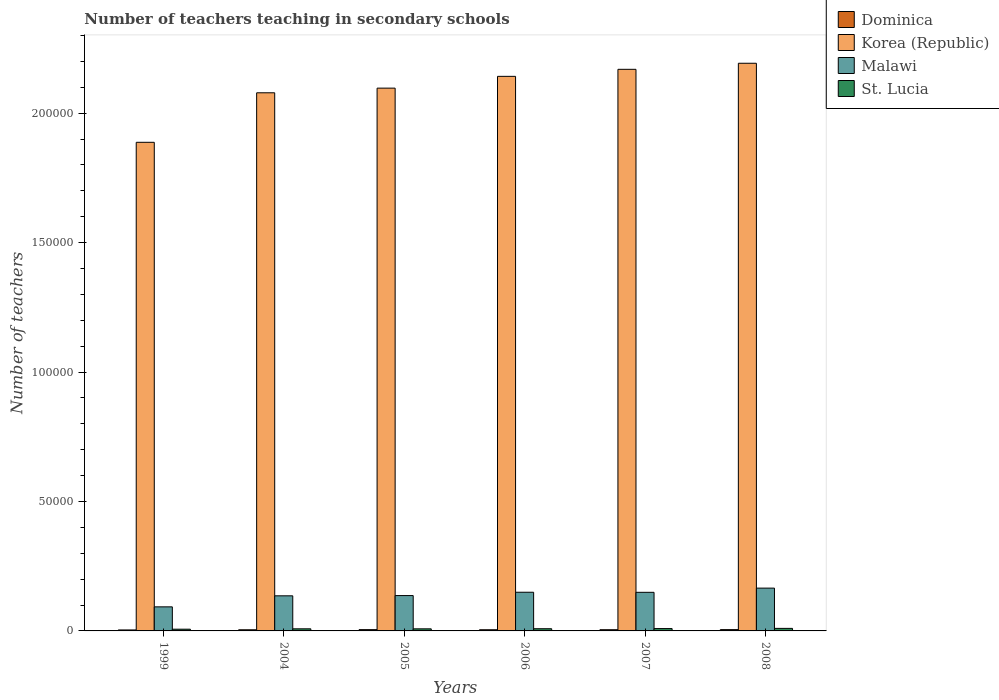How many groups of bars are there?
Provide a succinct answer. 6. Are the number of bars on each tick of the X-axis equal?
Make the answer very short. Yes. What is the label of the 5th group of bars from the left?
Your answer should be compact. 2007. In how many cases, is the number of bars for a given year not equal to the number of legend labels?
Give a very brief answer. 0. What is the number of teachers teaching in secondary schools in Malawi in 2006?
Keep it short and to the point. 1.49e+04. Across all years, what is the maximum number of teachers teaching in secondary schools in Dominica?
Provide a short and direct response. 506. Across all years, what is the minimum number of teachers teaching in secondary schools in Korea (Republic)?
Your answer should be very brief. 1.89e+05. What is the total number of teachers teaching in secondary schools in St. Lucia in the graph?
Your response must be concise. 5017. What is the difference between the number of teachers teaching in secondary schools in Malawi in 1999 and that in 2005?
Your response must be concise. -4358. What is the difference between the number of teachers teaching in secondary schools in Malawi in 2008 and the number of teachers teaching in secondary schools in Korea (Republic) in 2004?
Provide a short and direct response. -1.91e+05. What is the average number of teachers teaching in secondary schools in St. Lucia per year?
Your answer should be very brief. 836.17. In the year 1999, what is the difference between the number of teachers teaching in secondary schools in St. Lucia and number of teachers teaching in secondary schools in Dominica?
Make the answer very short. 293. What is the ratio of the number of teachers teaching in secondary schools in Dominica in 2004 to that in 2005?
Ensure brevity in your answer.  0.9. Is the number of teachers teaching in secondary schools in Malawi in 2005 less than that in 2007?
Provide a short and direct response. Yes. What is the difference between the highest and the second highest number of teachers teaching in secondary schools in Malawi?
Keep it short and to the point. 1596. What is the difference between the highest and the lowest number of teachers teaching in secondary schools in Dominica?
Offer a very short reply. 130. In how many years, is the number of teachers teaching in secondary schools in St. Lucia greater than the average number of teachers teaching in secondary schools in St. Lucia taken over all years?
Keep it short and to the point. 3. Is it the case that in every year, the sum of the number of teachers teaching in secondary schools in Dominica and number of teachers teaching in secondary schools in St. Lucia is greater than the sum of number of teachers teaching in secondary schools in Korea (Republic) and number of teachers teaching in secondary schools in Malawi?
Offer a terse response. Yes. What does the 4th bar from the left in 2007 represents?
Provide a short and direct response. St. Lucia. What does the 1st bar from the right in 2007 represents?
Offer a very short reply. St. Lucia. Is it the case that in every year, the sum of the number of teachers teaching in secondary schools in Korea (Republic) and number of teachers teaching in secondary schools in Malawi is greater than the number of teachers teaching in secondary schools in Dominica?
Provide a short and direct response. Yes. Are all the bars in the graph horizontal?
Ensure brevity in your answer.  No. How many years are there in the graph?
Keep it short and to the point. 6. What is the difference between two consecutive major ticks on the Y-axis?
Provide a succinct answer. 5.00e+04. Where does the legend appear in the graph?
Your answer should be compact. Top right. What is the title of the graph?
Offer a terse response. Number of teachers teaching in secondary schools. What is the label or title of the Y-axis?
Offer a very short reply. Number of teachers. What is the Number of teachers of Dominica in 1999?
Give a very brief answer. 376. What is the Number of teachers in Korea (Republic) in 1999?
Your response must be concise. 1.89e+05. What is the Number of teachers in Malawi in 1999?
Your answer should be compact. 9301. What is the Number of teachers in St. Lucia in 1999?
Keep it short and to the point. 669. What is the Number of teachers of Dominica in 2004?
Your response must be concise. 445. What is the Number of teachers in Korea (Republic) in 2004?
Offer a terse response. 2.08e+05. What is the Number of teachers of Malawi in 2004?
Offer a very short reply. 1.36e+04. What is the Number of teachers of St. Lucia in 2004?
Your answer should be compact. 814. What is the Number of teachers in Dominica in 2005?
Provide a short and direct response. 496. What is the Number of teachers of Korea (Republic) in 2005?
Keep it short and to the point. 2.10e+05. What is the Number of teachers in Malawi in 2005?
Ensure brevity in your answer.  1.37e+04. What is the Number of teachers of St. Lucia in 2005?
Make the answer very short. 803. What is the Number of teachers of Dominica in 2006?
Make the answer very short. 455. What is the Number of teachers of Korea (Republic) in 2006?
Keep it short and to the point. 2.14e+05. What is the Number of teachers in Malawi in 2006?
Offer a very short reply. 1.49e+04. What is the Number of teachers in St. Lucia in 2006?
Offer a terse response. 845. What is the Number of teachers of Dominica in 2007?
Offer a terse response. 469. What is the Number of teachers in Korea (Republic) in 2007?
Offer a terse response. 2.17e+05. What is the Number of teachers of Malawi in 2007?
Offer a terse response. 1.49e+04. What is the Number of teachers in St. Lucia in 2007?
Your answer should be compact. 907. What is the Number of teachers of Dominica in 2008?
Your answer should be very brief. 506. What is the Number of teachers in Korea (Republic) in 2008?
Your answer should be compact. 2.19e+05. What is the Number of teachers in Malawi in 2008?
Your answer should be very brief. 1.65e+04. What is the Number of teachers in St. Lucia in 2008?
Offer a very short reply. 979. Across all years, what is the maximum Number of teachers of Dominica?
Your answer should be compact. 506. Across all years, what is the maximum Number of teachers in Korea (Republic)?
Make the answer very short. 2.19e+05. Across all years, what is the maximum Number of teachers in Malawi?
Your response must be concise. 1.65e+04. Across all years, what is the maximum Number of teachers of St. Lucia?
Your answer should be compact. 979. Across all years, what is the minimum Number of teachers of Dominica?
Give a very brief answer. 376. Across all years, what is the minimum Number of teachers in Korea (Republic)?
Your answer should be compact. 1.89e+05. Across all years, what is the minimum Number of teachers in Malawi?
Offer a very short reply. 9301. Across all years, what is the minimum Number of teachers in St. Lucia?
Ensure brevity in your answer.  669. What is the total Number of teachers in Dominica in the graph?
Keep it short and to the point. 2747. What is the total Number of teachers in Korea (Republic) in the graph?
Make the answer very short. 1.26e+06. What is the total Number of teachers in Malawi in the graph?
Offer a very short reply. 8.29e+04. What is the total Number of teachers in St. Lucia in the graph?
Keep it short and to the point. 5017. What is the difference between the Number of teachers in Dominica in 1999 and that in 2004?
Your response must be concise. -69. What is the difference between the Number of teachers of Korea (Republic) in 1999 and that in 2004?
Make the answer very short. -1.91e+04. What is the difference between the Number of teachers of Malawi in 1999 and that in 2004?
Provide a succinct answer. -4256. What is the difference between the Number of teachers in St. Lucia in 1999 and that in 2004?
Your response must be concise. -145. What is the difference between the Number of teachers of Dominica in 1999 and that in 2005?
Your response must be concise. -120. What is the difference between the Number of teachers in Korea (Republic) in 1999 and that in 2005?
Keep it short and to the point. -2.09e+04. What is the difference between the Number of teachers of Malawi in 1999 and that in 2005?
Ensure brevity in your answer.  -4358. What is the difference between the Number of teachers of St. Lucia in 1999 and that in 2005?
Provide a short and direct response. -134. What is the difference between the Number of teachers in Dominica in 1999 and that in 2006?
Your answer should be very brief. -79. What is the difference between the Number of teachers of Korea (Republic) in 1999 and that in 2006?
Offer a very short reply. -2.55e+04. What is the difference between the Number of teachers in Malawi in 1999 and that in 2006?
Give a very brief answer. -5638. What is the difference between the Number of teachers of St. Lucia in 1999 and that in 2006?
Ensure brevity in your answer.  -176. What is the difference between the Number of teachers in Dominica in 1999 and that in 2007?
Make the answer very short. -93. What is the difference between the Number of teachers in Korea (Republic) in 1999 and that in 2007?
Your response must be concise. -2.82e+04. What is the difference between the Number of teachers in Malawi in 1999 and that in 2007?
Ensure brevity in your answer.  -5612. What is the difference between the Number of teachers of St. Lucia in 1999 and that in 2007?
Offer a terse response. -238. What is the difference between the Number of teachers of Dominica in 1999 and that in 2008?
Keep it short and to the point. -130. What is the difference between the Number of teachers of Korea (Republic) in 1999 and that in 2008?
Your answer should be very brief. -3.05e+04. What is the difference between the Number of teachers of Malawi in 1999 and that in 2008?
Ensure brevity in your answer.  -7234. What is the difference between the Number of teachers of St. Lucia in 1999 and that in 2008?
Give a very brief answer. -310. What is the difference between the Number of teachers of Dominica in 2004 and that in 2005?
Ensure brevity in your answer.  -51. What is the difference between the Number of teachers in Korea (Republic) in 2004 and that in 2005?
Provide a short and direct response. -1798. What is the difference between the Number of teachers in Malawi in 2004 and that in 2005?
Offer a terse response. -102. What is the difference between the Number of teachers of Dominica in 2004 and that in 2006?
Your response must be concise. -10. What is the difference between the Number of teachers of Korea (Republic) in 2004 and that in 2006?
Keep it short and to the point. -6350. What is the difference between the Number of teachers in Malawi in 2004 and that in 2006?
Give a very brief answer. -1382. What is the difference between the Number of teachers of St. Lucia in 2004 and that in 2006?
Your answer should be compact. -31. What is the difference between the Number of teachers of Korea (Republic) in 2004 and that in 2007?
Ensure brevity in your answer.  -9069. What is the difference between the Number of teachers of Malawi in 2004 and that in 2007?
Keep it short and to the point. -1356. What is the difference between the Number of teachers in St. Lucia in 2004 and that in 2007?
Ensure brevity in your answer.  -93. What is the difference between the Number of teachers in Dominica in 2004 and that in 2008?
Offer a terse response. -61. What is the difference between the Number of teachers of Korea (Republic) in 2004 and that in 2008?
Keep it short and to the point. -1.14e+04. What is the difference between the Number of teachers of Malawi in 2004 and that in 2008?
Ensure brevity in your answer.  -2978. What is the difference between the Number of teachers in St. Lucia in 2004 and that in 2008?
Your answer should be very brief. -165. What is the difference between the Number of teachers in Korea (Republic) in 2005 and that in 2006?
Provide a short and direct response. -4552. What is the difference between the Number of teachers in Malawi in 2005 and that in 2006?
Provide a short and direct response. -1280. What is the difference between the Number of teachers of St. Lucia in 2005 and that in 2006?
Keep it short and to the point. -42. What is the difference between the Number of teachers in Korea (Republic) in 2005 and that in 2007?
Provide a short and direct response. -7271. What is the difference between the Number of teachers in Malawi in 2005 and that in 2007?
Provide a short and direct response. -1254. What is the difference between the Number of teachers of St. Lucia in 2005 and that in 2007?
Your response must be concise. -104. What is the difference between the Number of teachers in Dominica in 2005 and that in 2008?
Your response must be concise. -10. What is the difference between the Number of teachers of Korea (Republic) in 2005 and that in 2008?
Your response must be concise. -9612. What is the difference between the Number of teachers in Malawi in 2005 and that in 2008?
Give a very brief answer. -2876. What is the difference between the Number of teachers of St. Lucia in 2005 and that in 2008?
Give a very brief answer. -176. What is the difference between the Number of teachers of Korea (Republic) in 2006 and that in 2007?
Provide a succinct answer. -2719. What is the difference between the Number of teachers of St. Lucia in 2006 and that in 2007?
Your answer should be very brief. -62. What is the difference between the Number of teachers in Dominica in 2006 and that in 2008?
Provide a short and direct response. -51. What is the difference between the Number of teachers in Korea (Republic) in 2006 and that in 2008?
Your answer should be very brief. -5060. What is the difference between the Number of teachers of Malawi in 2006 and that in 2008?
Your answer should be very brief. -1596. What is the difference between the Number of teachers in St. Lucia in 2006 and that in 2008?
Your response must be concise. -134. What is the difference between the Number of teachers of Dominica in 2007 and that in 2008?
Your response must be concise. -37. What is the difference between the Number of teachers of Korea (Republic) in 2007 and that in 2008?
Ensure brevity in your answer.  -2341. What is the difference between the Number of teachers of Malawi in 2007 and that in 2008?
Ensure brevity in your answer.  -1622. What is the difference between the Number of teachers in St. Lucia in 2007 and that in 2008?
Provide a succinct answer. -72. What is the difference between the Number of teachers of Dominica in 1999 and the Number of teachers of Korea (Republic) in 2004?
Provide a short and direct response. -2.08e+05. What is the difference between the Number of teachers in Dominica in 1999 and the Number of teachers in Malawi in 2004?
Provide a succinct answer. -1.32e+04. What is the difference between the Number of teachers of Dominica in 1999 and the Number of teachers of St. Lucia in 2004?
Offer a very short reply. -438. What is the difference between the Number of teachers of Korea (Republic) in 1999 and the Number of teachers of Malawi in 2004?
Provide a short and direct response. 1.75e+05. What is the difference between the Number of teachers of Korea (Republic) in 1999 and the Number of teachers of St. Lucia in 2004?
Ensure brevity in your answer.  1.88e+05. What is the difference between the Number of teachers in Malawi in 1999 and the Number of teachers in St. Lucia in 2004?
Provide a short and direct response. 8487. What is the difference between the Number of teachers in Dominica in 1999 and the Number of teachers in Korea (Republic) in 2005?
Your answer should be compact. -2.09e+05. What is the difference between the Number of teachers of Dominica in 1999 and the Number of teachers of Malawi in 2005?
Give a very brief answer. -1.33e+04. What is the difference between the Number of teachers in Dominica in 1999 and the Number of teachers in St. Lucia in 2005?
Provide a short and direct response. -427. What is the difference between the Number of teachers of Korea (Republic) in 1999 and the Number of teachers of Malawi in 2005?
Offer a terse response. 1.75e+05. What is the difference between the Number of teachers in Korea (Republic) in 1999 and the Number of teachers in St. Lucia in 2005?
Offer a very short reply. 1.88e+05. What is the difference between the Number of teachers of Malawi in 1999 and the Number of teachers of St. Lucia in 2005?
Offer a very short reply. 8498. What is the difference between the Number of teachers in Dominica in 1999 and the Number of teachers in Korea (Republic) in 2006?
Offer a very short reply. -2.14e+05. What is the difference between the Number of teachers of Dominica in 1999 and the Number of teachers of Malawi in 2006?
Your answer should be compact. -1.46e+04. What is the difference between the Number of teachers of Dominica in 1999 and the Number of teachers of St. Lucia in 2006?
Make the answer very short. -469. What is the difference between the Number of teachers of Korea (Republic) in 1999 and the Number of teachers of Malawi in 2006?
Ensure brevity in your answer.  1.74e+05. What is the difference between the Number of teachers in Korea (Republic) in 1999 and the Number of teachers in St. Lucia in 2006?
Your answer should be very brief. 1.88e+05. What is the difference between the Number of teachers of Malawi in 1999 and the Number of teachers of St. Lucia in 2006?
Keep it short and to the point. 8456. What is the difference between the Number of teachers in Dominica in 1999 and the Number of teachers in Korea (Republic) in 2007?
Your answer should be very brief. -2.17e+05. What is the difference between the Number of teachers of Dominica in 1999 and the Number of teachers of Malawi in 2007?
Your answer should be very brief. -1.45e+04. What is the difference between the Number of teachers of Dominica in 1999 and the Number of teachers of St. Lucia in 2007?
Keep it short and to the point. -531. What is the difference between the Number of teachers of Korea (Republic) in 1999 and the Number of teachers of Malawi in 2007?
Make the answer very short. 1.74e+05. What is the difference between the Number of teachers of Korea (Republic) in 1999 and the Number of teachers of St. Lucia in 2007?
Ensure brevity in your answer.  1.88e+05. What is the difference between the Number of teachers in Malawi in 1999 and the Number of teachers in St. Lucia in 2007?
Ensure brevity in your answer.  8394. What is the difference between the Number of teachers in Dominica in 1999 and the Number of teachers in Korea (Republic) in 2008?
Your response must be concise. -2.19e+05. What is the difference between the Number of teachers in Dominica in 1999 and the Number of teachers in Malawi in 2008?
Give a very brief answer. -1.62e+04. What is the difference between the Number of teachers in Dominica in 1999 and the Number of teachers in St. Lucia in 2008?
Give a very brief answer. -603. What is the difference between the Number of teachers in Korea (Republic) in 1999 and the Number of teachers in Malawi in 2008?
Your answer should be compact. 1.72e+05. What is the difference between the Number of teachers in Korea (Republic) in 1999 and the Number of teachers in St. Lucia in 2008?
Offer a terse response. 1.88e+05. What is the difference between the Number of teachers of Malawi in 1999 and the Number of teachers of St. Lucia in 2008?
Offer a terse response. 8322. What is the difference between the Number of teachers of Dominica in 2004 and the Number of teachers of Korea (Republic) in 2005?
Provide a succinct answer. -2.09e+05. What is the difference between the Number of teachers of Dominica in 2004 and the Number of teachers of Malawi in 2005?
Offer a very short reply. -1.32e+04. What is the difference between the Number of teachers in Dominica in 2004 and the Number of teachers in St. Lucia in 2005?
Your answer should be very brief. -358. What is the difference between the Number of teachers of Korea (Republic) in 2004 and the Number of teachers of Malawi in 2005?
Your answer should be compact. 1.94e+05. What is the difference between the Number of teachers of Korea (Republic) in 2004 and the Number of teachers of St. Lucia in 2005?
Ensure brevity in your answer.  2.07e+05. What is the difference between the Number of teachers of Malawi in 2004 and the Number of teachers of St. Lucia in 2005?
Your response must be concise. 1.28e+04. What is the difference between the Number of teachers of Dominica in 2004 and the Number of teachers of Korea (Republic) in 2006?
Your answer should be compact. -2.14e+05. What is the difference between the Number of teachers in Dominica in 2004 and the Number of teachers in Malawi in 2006?
Provide a succinct answer. -1.45e+04. What is the difference between the Number of teachers in Dominica in 2004 and the Number of teachers in St. Lucia in 2006?
Offer a very short reply. -400. What is the difference between the Number of teachers of Korea (Republic) in 2004 and the Number of teachers of Malawi in 2006?
Give a very brief answer. 1.93e+05. What is the difference between the Number of teachers in Korea (Republic) in 2004 and the Number of teachers in St. Lucia in 2006?
Your answer should be compact. 2.07e+05. What is the difference between the Number of teachers in Malawi in 2004 and the Number of teachers in St. Lucia in 2006?
Your answer should be compact. 1.27e+04. What is the difference between the Number of teachers in Dominica in 2004 and the Number of teachers in Korea (Republic) in 2007?
Keep it short and to the point. -2.17e+05. What is the difference between the Number of teachers of Dominica in 2004 and the Number of teachers of Malawi in 2007?
Your response must be concise. -1.45e+04. What is the difference between the Number of teachers in Dominica in 2004 and the Number of teachers in St. Lucia in 2007?
Your answer should be compact. -462. What is the difference between the Number of teachers of Korea (Republic) in 2004 and the Number of teachers of Malawi in 2007?
Give a very brief answer. 1.93e+05. What is the difference between the Number of teachers of Korea (Republic) in 2004 and the Number of teachers of St. Lucia in 2007?
Your answer should be very brief. 2.07e+05. What is the difference between the Number of teachers of Malawi in 2004 and the Number of teachers of St. Lucia in 2007?
Your answer should be compact. 1.26e+04. What is the difference between the Number of teachers of Dominica in 2004 and the Number of teachers of Korea (Republic) in 2008?
Your answer should be compact. -2.19e+05. What is the difference between the Number of teachers in Dominica in 2004 and the Number of teachers in Malawi in 2008?
Your answer should be compact. -1.61e+04. What is the difference between the Number of teachers of Dominica in 2004 and the Number of teachers of St. Lucia in 2008?
Keep it short and to the point. -534. What is the difference between the Number of teachers in Korea (Republic) in 2004 and the Number of teachers in Malawi in 2008?
Give a very brief answer. 1.91e+05. What is the difference between the Number of teachers in Korea (Republic) in 2004 and the Number of teachers in St. Lucia in 2008?
Provide a short and direct response. 2.07e+05. What is the difference between the Number of teachers of Malawi in 2004 and the Number of teachers of St. Lucia in 2008?
Ensure brevity in your answer.  1.26e+04. What is the difference between the Number of teachers in Dominica in 2005 and the Number of teachers in Korea (Republic) in 2006?
Ensure brevity in your answer.  -2.14e+05. What is the difference between the Number of teachers of Dominica in 2005 and the Number of teachers of Malawi in 2006?
Provide a succinct answer. -1.44e+04. What is the difference between the Number of teachers of Dominica in 2005 and the Number of teachers of St. Lucia in 2006?
Keep it short and to the point. -349. What is the difference between the Number of teachers of Korea (Republic) in 2005 and the Number of teachers of Malawi in 2006?
Offer a very short reply. 1.95e+05. What is the difference between the Number of teachers of Korea (Republic) in 2005 and the Number of teachers of St. Lucia in 2006?
Your response must be concise. 2.09e+05. What is the difference between the Number of teachers of Malawi in 2005 and the Number of teachers of St. Lucia in 2006?
Your answer should be very brief. 1.28e+04. What is the difference between the Number of teachers of Dominica in 2005 and the Number of teachers of Korea (Republic) in 2007?
Offer a terse response. -2.16e+05. What is the difference between the Number of teachers in Dominica in 2005 and the Number of teachers in Malawi in 2007?
Offer a very short reply. -1.44e+04. What is the difference between the Number of teachers of Dominica in 2005 and the Number of teachers of St. Lucia in 2007?
Your answer should be very brief. -411. What is the difference between the Number of teachers in Korea (Republic) in 2005 and the Number of teachers in Malawi in 2007?
Offer a very short reply. 1.95e+05. What is the difference between the Number of teachers in Korea (Republic) in 2005 and the Number of teachers in St. Lucia in 2007?
Offer a very short reply. 2.09e+05. What is the difference between the Number of teachers of Malawi in 2005 and the Number of teachers of St. Lucia in 2007?
Give a very brief answer. 1.28e+04. What is the difference between the Number of teachers in Dominica in 2005 and the Number of teachers in Korea (Republic) in 2008?
Ensure brevity in your answer.  -2.19e+05. What is the difference between the Number of teachers of Dominica in 2005 and the Number of teachers of Malawi in 2008?
Offer a terse response. -1.60e+04. What is the difference between the Number of teachers of Dominica in 2005 and the Number of teachers of St. Lucia in 2008?
Provide a short and direct response. -483. What is the difference between the Number of teachers in Korea (Republic) in 2005 and the Number of teachers in Malawi in 2008?
Offer a very short reply. 1.93e+05. What is the difference between the Number of teachers of Korea (Republic) in 2005 and the Number of teachers of St. Lucia in 2008?
Make the answer very short. 2.09e+05. What is the difference between the Number of teachers of Malawi in 2005 and the Number of teachers of St. Lucia in 2008?
Your answer should be compact. 1.27e+04. What is the difference between the Number of teachers in Dominica in 2006 and the Number of teachers in Korea (Republic) in 2007?
Ensure brevity in your answer.  -2.16e+05. What is the difference between the Number of teachers in Dominica in 2006 and the Number of teachers in Malawi in 2007?
Provide a short and direct response. -1.45e+04. What is the difference between the Number of teachers of Dominica in 2006 and the Number of teachers of St. Lucia in 2007?
Offer a terse response. -452. What is the difference between the Number of teachers of Korea (Republic) in 2006 and the Number of teachers of Malawi in 2007?
Offer a very short reply. 1.99e+05. What is the difference between the Number of teachers of Korea (Republic) in 2006 and the Number of teachers of St. Lucia in 2007?
Ensure brevity in your answer.  2.13e+05. What is the difference between the Number of teachers of Malawi in 2006 and the Number of teachers of St. Lucia in 2007?
Offer a terse response. 1.40e+04. What is the difference between the Number of teachers in Dominica in 2006 and the Number of teachers in Korea (Republic) in 2008?
Give a very brief answer. -2.19e+05. What is the difference between the Number of teachers in Dominica in 2006 and the Number of teachers in Malawi in 2008?
Your response must be concise. -1.61e+04. What is the difference between the Number of teachers of Dominica in 2006 and the Number of teachers of St. Lucia in 2008?
Offer a terse response. -524. What is the difference between the Number of teachers of Korea (Republic) in 2006 and the Number of teachers of Malawi in 2008?
Provide a succinct answer. 1.98e+05. What is the difference between the Number of teachers of Korea (Republic) in 2006 and the Number of teachers of St. Lucia in 2008?
Give a very brief answer. 2.13e+05. What is the difference between the Number of teachers in Malawi in 2006 and the Number of teachers in St. Lucia in 2008?
Offer a very short reply. 1.40e+04. What is the difference between the Number of teachers in Dominica in 2007 and the Number of teachers in Korea (Republic) in 2008?
Keep it short and to the point. -2.19e+05. What is the difference between the Number of teachers in Dominica in 2007 and the Number of teachers in Malawi in 2008?
Provide a succinct answer. -1.61e+04. What is the difference between the Number of teachers of Dominica in 2007 and the Number of teachers of St. Lucia in 2008?
Your response must be concise. -510. What is the difference between the Number of teachers of Korea (Republic) in 2007 and the Number of teachers of Malawi in 2008?
Provide a succinct answer. 2.00e+05. What is the difference between the Number of teachers in Korea (Republic) in 2007 and the Number of teachers in St. Lucia in 2008?
Provide a succinct answer. 2.16e+05. What is the difference between the Number of teachers in Malawi in 2007 and the Number of teachers in St. Lucia in 2008?
Keep it short and to the point. 1.39e+04. What is the average Number of teachers of Dominica per year?
Make the answer very short. 457.83. What is the average Number of teachers of Korea (Republic) per year?
Offer a very short reply. 2.09e+05. What is the average Number of teachers in Malawi per year?
Keep it short and to the point. 1.38e+04. What is the average Number of teachers of St. Lucia per year?
Offer a very short reply. 836.17. In the year 1999, what is the difference between the Number of teachers of Dominica and Number of teachers of Korea (Republic)?
Make the answer very short. -1.88e+05. In the year 1999, what is the difference between the Number of teachers in Dominica and Number of teachers in Malawi?
Provide a short and direct response. -8925. In the year 1999, what is the difference between the Number of teachers in Dominica and Number of teachers in St. Lucia?
Provide a short and direct response. -293. In the year 1999, what is the difference between the Number of teachers of Korea (Republic) and Number of teachers of Malawi?
Provide a short and direct response. 1.79e+05. In the year 1999, what is the difference between the Number of teachers of Korea (Republic) and Number of teachers of St. Lucia?
Your answer should be compact. 1.88e+05. In the year 1999, what is the difference between the Number of teachers in Malawi and Number of teachers in St. Lucia?
Provide a succinct answer. 8632. In the year 2004, what is the difference between the Number of teachers in Dominica and Number of teachers in Korea (Republic)?
Make the answer very short. -2.07e+05. In the year 2004, what is the difference between the Number of teachers in Dominica and Number of teachers in Malawi?
Provide a short and direct response. -1.31e+04. In the year 2004, what is the difference between the Number of teachers in Dominica and Number of teachers in St. Lucia?
Offer a terse response. -369. In the year 2004, what is the difference between the Number of teachers in Korea (Republic) and Number of teachers in Malawi?
Offer a terse response. 1.94e+05. In the year 2004, what is the difference between the Number of teachers in Korea (Republic) and Number of teachers in St. Lucia?
Your answer should be compact. 2.07e+05. In the year 2004, what is the difference between the Number of teachers of Malawi and Number of teachers of St. Lucia?
Keep it short and to the point. 1.27e+04. In the year 2005, what is the difference between the Number of teachers in Dominica and Number of teachers in Korea (Republic)?
Offer a very short reply. -2.09e+05. In the year 2005, what is the difference between the Number of teachers in Dominica and Number of teachers in Malawi?
Offer a terse response. -1.32e+04. In the year 2005, what is the difference between the Number of teachers in Dominica and Number of teachers in St. Lucia?
Provide a short and direct response. -307. In the year 2005, what is the difference between the Number of teachers of Korea (Republic) and Number of teachers of Malawi?
Make the answer very short. 1.96e+05. In the year 2005, what is the difference between the Number of teachers in Korea (Republic) and Number of teachers in St. Lucia?
Provide a short and direct response. 2.09e+05. In the year 2005, what is the difference between the Number of teachers in Malawi and Number of teachers in St. Lucia?
Provide a short and direct response. 1.29e+04. In the year 2006, what is the difference between the Number of teachers in Dominica and Number of teachers in Korea (Republic)?
Keep it short and to the point. -2.14e+05. In the year 2006, what is the difference between the Number of teachers of Dominica and Number of teachers of Malawi?
Your answer should be compact. -1.45e+04. In the year 2006, what is the difference between the Number of teachers in Dominica and Number of teachers in St. Lucia?
Your response must be concise. -390. In the year 2006, what is the difference between the Number of teachers of Korea (Republic) and Number of teachers of Malawi?
Make the answer very short. 1.99e+05. In the year 2006, what is the difference between the Number of teachers of Korea (Republic) and Number of teachers of St. Lucia?
Provide a short and direct response. 2.13e+05. In the year 2006, what is the difference between the Number of teachers in Malawi and Number of teachers in St. Lucia?
Make the answer very short. 1.41e+04. In the year 2007, what is the difference between the Number of teachers of Dominica and Number of teachers of Korea (Republic)?
Your answer should be compact. -2.16e+05. In the year 2007, what is the difference between the Number of teachers in Dominica and Number of teachers in Malawi?
Offer a terse response. -1.44e+04. In the year 2007, what is the difference between the Number of teachers of Dominica and Number of teachers of St. Lucia?
Provide a short and direct response. -438. In the year 2007, what is the difference between the Number of teachers of Korea (Republic) and Number of teachers of Malawi?
Give a very brief answer. 2.02e+05. In the year 2007, what is the difference between the Number of teachers of Korea (Republic) and Number of teachers of St. Lucia?
Your response must be concise. 2.16e+05. In the year 2007, what is the difference between the Number of teachers in Malawi and Number of teachers in St. Lucia?
Keep it short and to the point. 1.40e+04. In the year 2008, what is the difference between the Number of teachers of Dominica and Number of teachers of Korea (Republic)?
Your answer should be compact. -2.19e+05. In the year 2008, what is the difference between the Number of teachers in Dominica and Number of teachers in Malawi?
Give a very brief answer. -1.60e+04. In the year 2008, what is the difference between the Number of teachers of Dominica and Number of teachers of St. Lucia?
Offer a terse response. -473. In the year 2008, what is the difference between the Number of teachers in Korea (Republic) and Number of teachers in Malawi?
Ensure brevity in your answer.  2.03e+05. In the year 2008, what is the difference between the Number of teachers in Korea (Republic) and Number of teachers in St. Lucia?
Give a very brief answer. 2.18e+05. In the year 2008, what is the difference between the Number of teachers of Malawi and Number of teachers of St. Lucia?
Provide a succinct answer. 1.56e+04. What is the ratio of the Number of teachers in Dominica in 1999 to that in 2004?
Your answer should be compact. 0.84. What is the ratio of the Number of teachers of Korea (Republic) in 1999 to that in 2004?
Give a very brief answer. 0.91. What is the ratio of the Number of teachers in Malawi in 1999 to that in 2004?
Give a very brief answer. 0.69. What is the ratio of the Number of teachers of St. Lucia in 1999 to that in 2004?
Offer a terse response. 0.82. What is the ratio of the Number of teachers of Dominica in 1999 to that in 2005?
Your answer should be compact. 0.76. What is the ratio of the Number of teachers in Korea (Republic) in 1999 to that in 2005?
Provide a short and direct response. 0.9. What is the ratio of the Number of teachers of Malawi in 1999 to that in 2005?
Make the answer very short. 0.68. What is the ratio of the Number of teachers of St. Lucia in 1999 to that in 2005?
Provide a short and direct response. 0.83. What is the ratio of the Number of teachers of Dominica in 1999 to that in 2006?
Your response must be concise. 0.83. What is the ratio of the Number of teachers in Korea (Republic) in 1999 to that in 2006?
Keep it short and to the point. 0.88. What is the ratio of the Number of teachers of Malawi in 1999 to that in 2006?
Ensure brevity in your answer.  0.62. What is the ratio of the Number of teachers of St. Lucia in 1999 to that in 2006?
Your answer should be very brief. 0.79. What is the ratio of the Number of teachers in Dominica in 1999 to that in 2007?
Your answer should be compact. 0.8. What is the ratio of the Number of teachers in Korea (Republic) in 1999 to that in 2007?
Ensure brevity in your answer.  0.87. What is the ratio of the Number of teachers of Malawi in 1999 to that in 2007?
Provide a succinct answer. 0.62. What is the ratio of the Number of teachers in St. Lucia in 1999 to that in 2007?
Offer a very short reply. 0.74. What is the ratio of the Number of teachers in Dominica in 1999 to that in 2008?
Your response must be concise. 0.74. What is the ratio of the Number of teachers of Korea (Republic) in 1999 to that in 2008?
Your answer should be compact. 0.86. What is the ratio of the Number of teachers of Malawi in 1999 to that in 2008?
Your answer should be very brief. 0.56. What is the ratio of the Number of teachers of St. Lucia in 1999 to that in 2008?
Your response must be concise. 0.68. What is the ratio of the Number of teachers in Dominica in 2004 to that in 2005?
Provide a short and direct response. 0.9. What is the ratio of the Number of teachers of St. Lucia in 2004 to that in 2005?
Make the answer very short. 1.01. What is the ratio of the Number of teachers of Dominica in 2004 to that in 2006?
Provide a short and direct response. 0.98. What is the ratio of the Number of teachers in Korea (Republic) in 2004 to that in 2006?
Provide a succinct answer. 0.97. What is the ratio of the Number of teachers of Malawi in 2004 to that in 2006?
Provide a short and direct response. 0.91. What is the ratio of the Number of teachers in St. Lucia in 2004 to that in 2006?
Ensure brevity in your answer.  0.96. What is the ratio of the Number of teachers in Dominica in 2004 to that in 2007?
Offer a terse response. 0.95. What is the ratio of the Number of teachers in Korea (Republic) in 2004 to that in 2007?
Offer a very short reply. 0.96. What is the ratio of the Number of teachers of St. Lucia in 2004 to that in 2007?
Your answer should be very brief. 0.9. What is the ratio of the Number of teachers of Dominica in 2004 to that in 2008?
Keep it short and to the point. 0.88. What is the ratio of the Number of teachers of Korea (Republic) in 2004 to that in 2008?
Keep it short and to the point. 0.95. What is the ratio of the Number of teachers in Malawi in 2004 to that in 2008?
Make the answer very short. 0.82. What is the ratio of the Number of teachers in St. Lucia in 2004 to that in 2008?
Ensure brevity in your answer.  0.83. What is the ratio of the Number of teachers in Dominica in 2005 to that in 2006?
Offer a terse response. 1.09. What is the ratio of the Number of teachers in Korea (Republic) in 2005 to that in 2006?
Make the answer very short. 0.98. What is the ratio of the Number of teachers in Malawi in 2005 to that in 2006?
Provide a short and direct response. 0.91. What is the ratio of the Number of teachers in St. Lucia in 2005 to that in 2006?
Your answer should be compact. 0.95. What is the ratio of the Number of teachers of Dominica in 2005 to that in 2007?
Make the answer very short. 1.06. What is the ratio of the Number of teachers of Korea (Republic) in 2005 to that in 2007?
Make the answer very short. 0.97. What is the ratio of the Number of teachers of Malawi in 2005 to that in 2007?
Make the answer very short. 0.92. What is the ratio of the Number of teachers in St. Lucia in 2005 to that in 2007?
Offer a very short reply. 0.89. What is the ratio of the Number of teachers of Dominica in 2005 to that in 2008?
Your answer should be very brief. 0.98. What is the ratio of the Number of teachers of Korea (Republic) in 2005 to that in 2008?
Offer a terse response. 0.96. What is the ratio of the Number of teachers in Malawi in 2005 to that in 2008?
Your answer should be compact. 0.83. What is the ratio of the Number of teachers in St. Lucia in 2005 to that in 2008?
Offer a terse response. 0.82. What is the ratio of the Number of teachers in Dominica in 2006 to that in 2007?
Make the answer very short. 0.97. What is the ratio of the Number of teachers of Korea (Republic) in 2006 to that in 2007?
Keep it short and to the point. 0.99. What is the ratio of the Number of teachers in Malawi in 2006 to that in 2007?
Provide a short and direct response. 1. What is the ratio of the Number of teachers in St. Lucia in 2006 to that in 2007?
Provide a short and direct response. 0.93. What is the ratio of the Number of teachers in Dominica in 2006 to that in 2008?
Your response must be concise. 0.9. What is the ratio of the Number of teachers in Korea (Republic) in 2006 to that in 2008?
Your response must be concise. 0.98. What is the ratio of the Number of teachers of Malawi in 2006 to that in 2008?
Your answer should be compact. 0.9. What is the ratio of the Number of teachers of St. Lucia in 2006 to that in 2008?
Provide a short and direct response. 0.86. What is the ratio of the Number of teachers in Dominica in 2007 to that in 2008?
Your answer should be compact. 0.93. What is the ratio of the Number of teachers in Korea (Republic) in 2007 to that in 2008?
Give a very brief answer. 0.99. What is the ratio of the Number of teachers in Malawi in 2007 to that in 2008?
Provide a succinct answer. 0.9. What is the ratio of the Number of teachers of St. Lucia in 2007 to that in 2008?
Make the answer very short. 0.93. What is the difference between the highest and the second highest Number of teachers of Dominica?
Give a very brief answer. 10. What is the difference between the highest and the second highest Number of teachers in Korea (Republic)?
Keep it short and to the point. 2341. What is the difference between the highest and the second highest Number of teachers of Malawi?
Your answer should be compact. 1596. What is the difference between the highest and the lowest Number of teachers of Dominica?
Offer a very short reply. 130. What is the difference between the highest and the lowest Number of teachers in Korea (Republic)?
Provide a short and direct response. 3.05e+04. What is the difference between the highest and the lowest Number of teachers in Malawi?
Make the answer very short. 7234. What is the difference between the highest and the lowest Number of teachers of St. Lucia?
Provide a short and direct response. 310. 